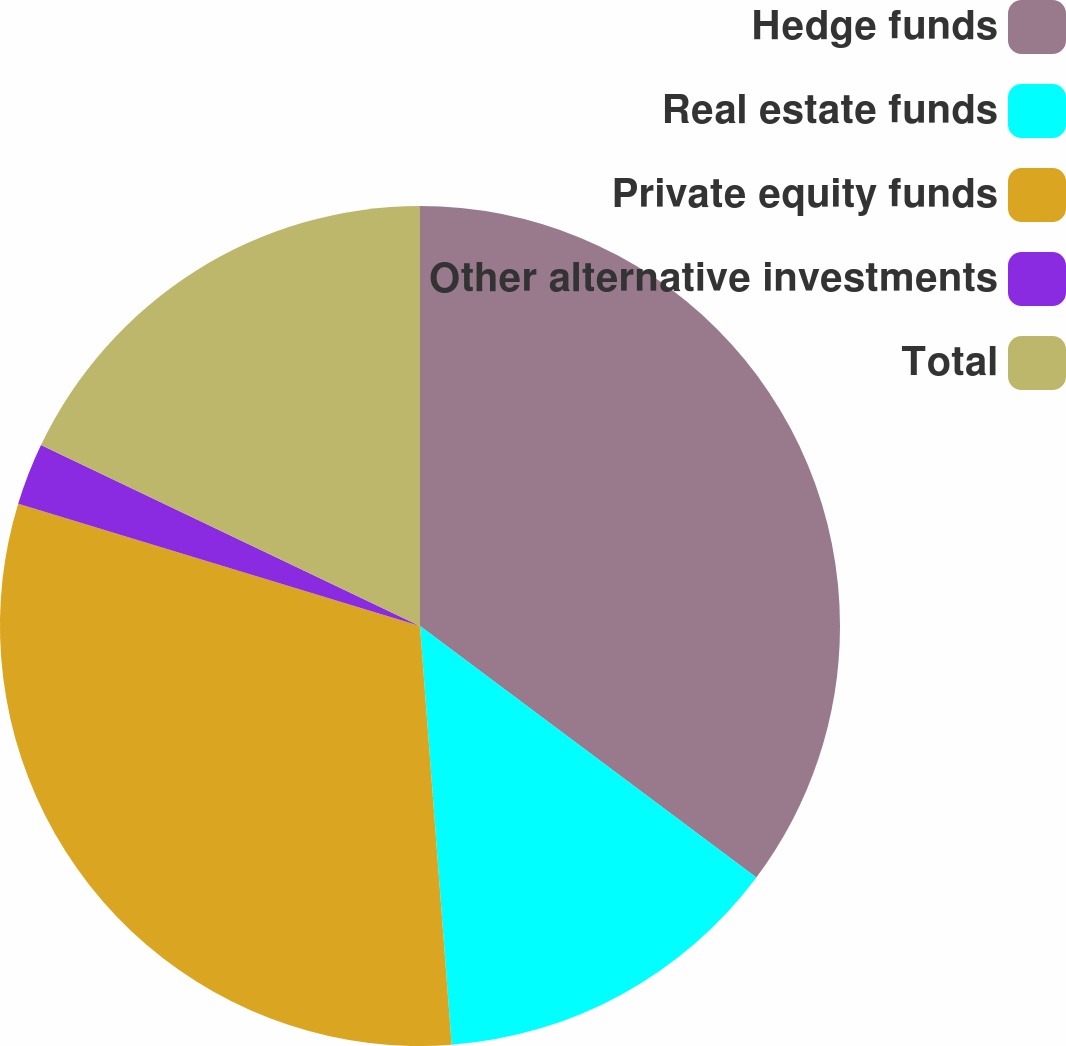<chart> <loc_0><loc_0><loc_500><loc_500><pie_chart><fcel>Hedge funds<fcel>Real estate funds<fcel>Private equity funds<fcel>Other alternative investments<fcel>Total<nl><fcel>35.22%<fcel>13.58%<fcel>30.9%<fcel>2.39%<fcel>17.91%<nl></chart> 